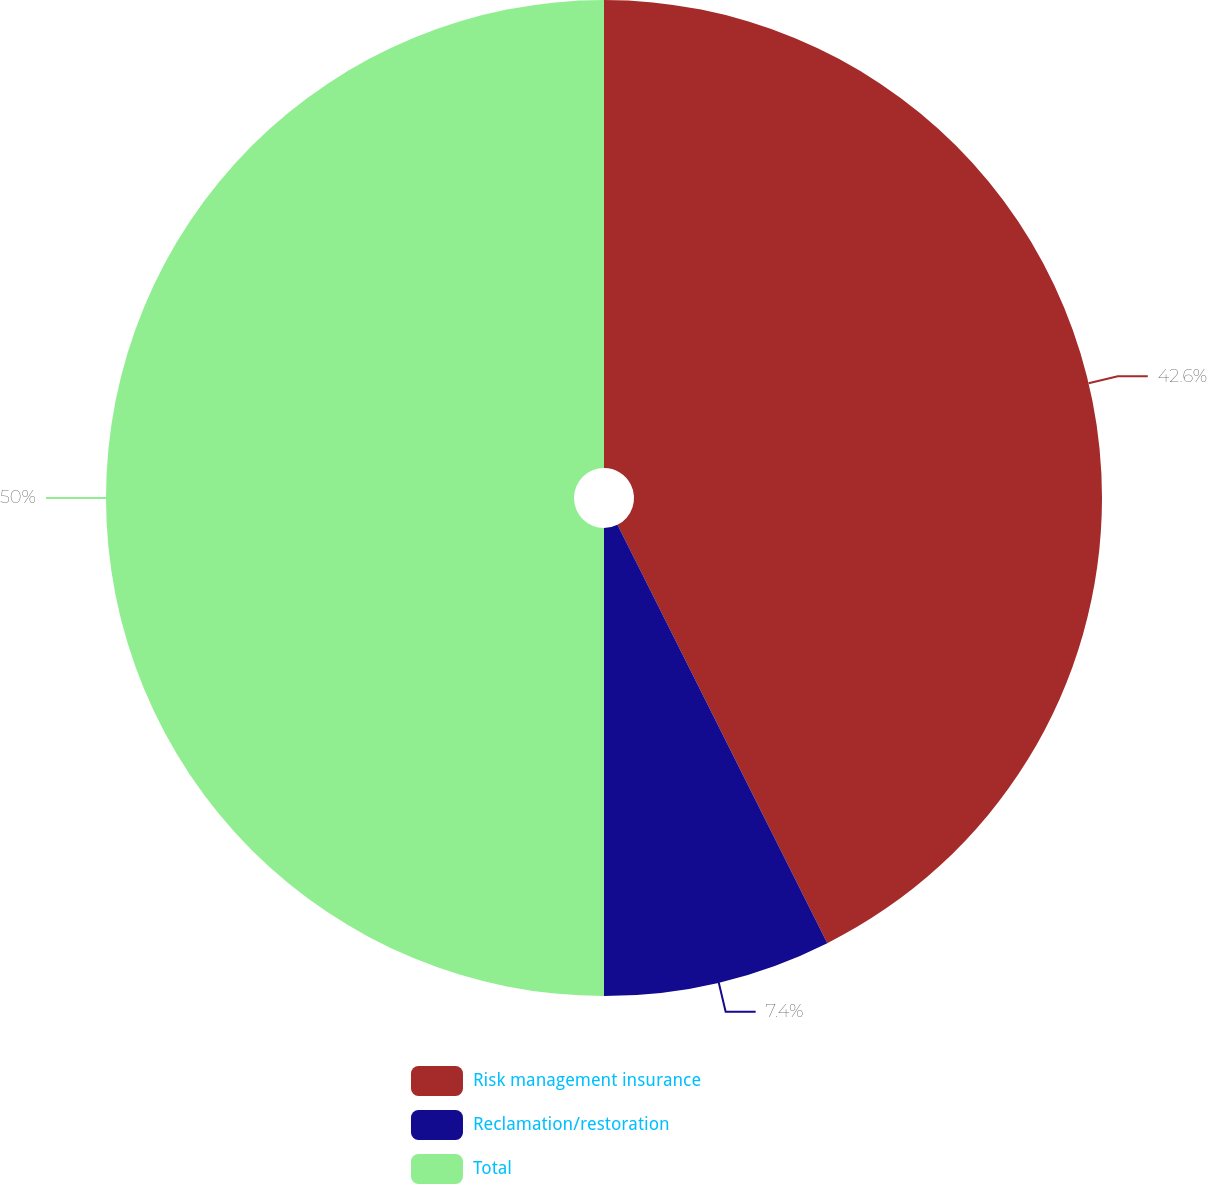<chart> <loc_0><loc_0><loc_500><loc_500><pie_chart><fcel>Risk management insurance<fcel>Reclamation/restoration<fcel>Total<nl><fcel>42.6%<fcel>7.4%<fcel>50.0%<nl></chart> 